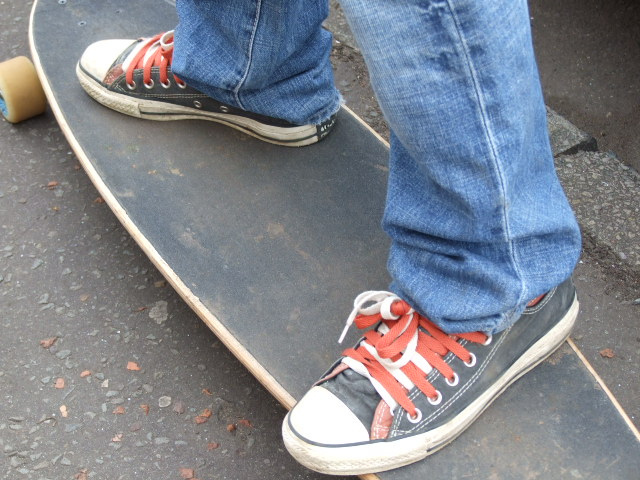What does the condition of the shoes suggest about the user? The worn and scuffed condition of these sneakers suggests they're well-loved and frequently used. It speaks to the durability of the brand and the active lifestyle of the wearer, possibly indicating regular engagement in skateboarding or outdoor activities. Why might someone choose this type of footwear? Someone might choose these sneakers for their comfort, versatility, and timeless style. Additionally, they might appreciate the association with subcultures that endorse individuality and self-expression. 